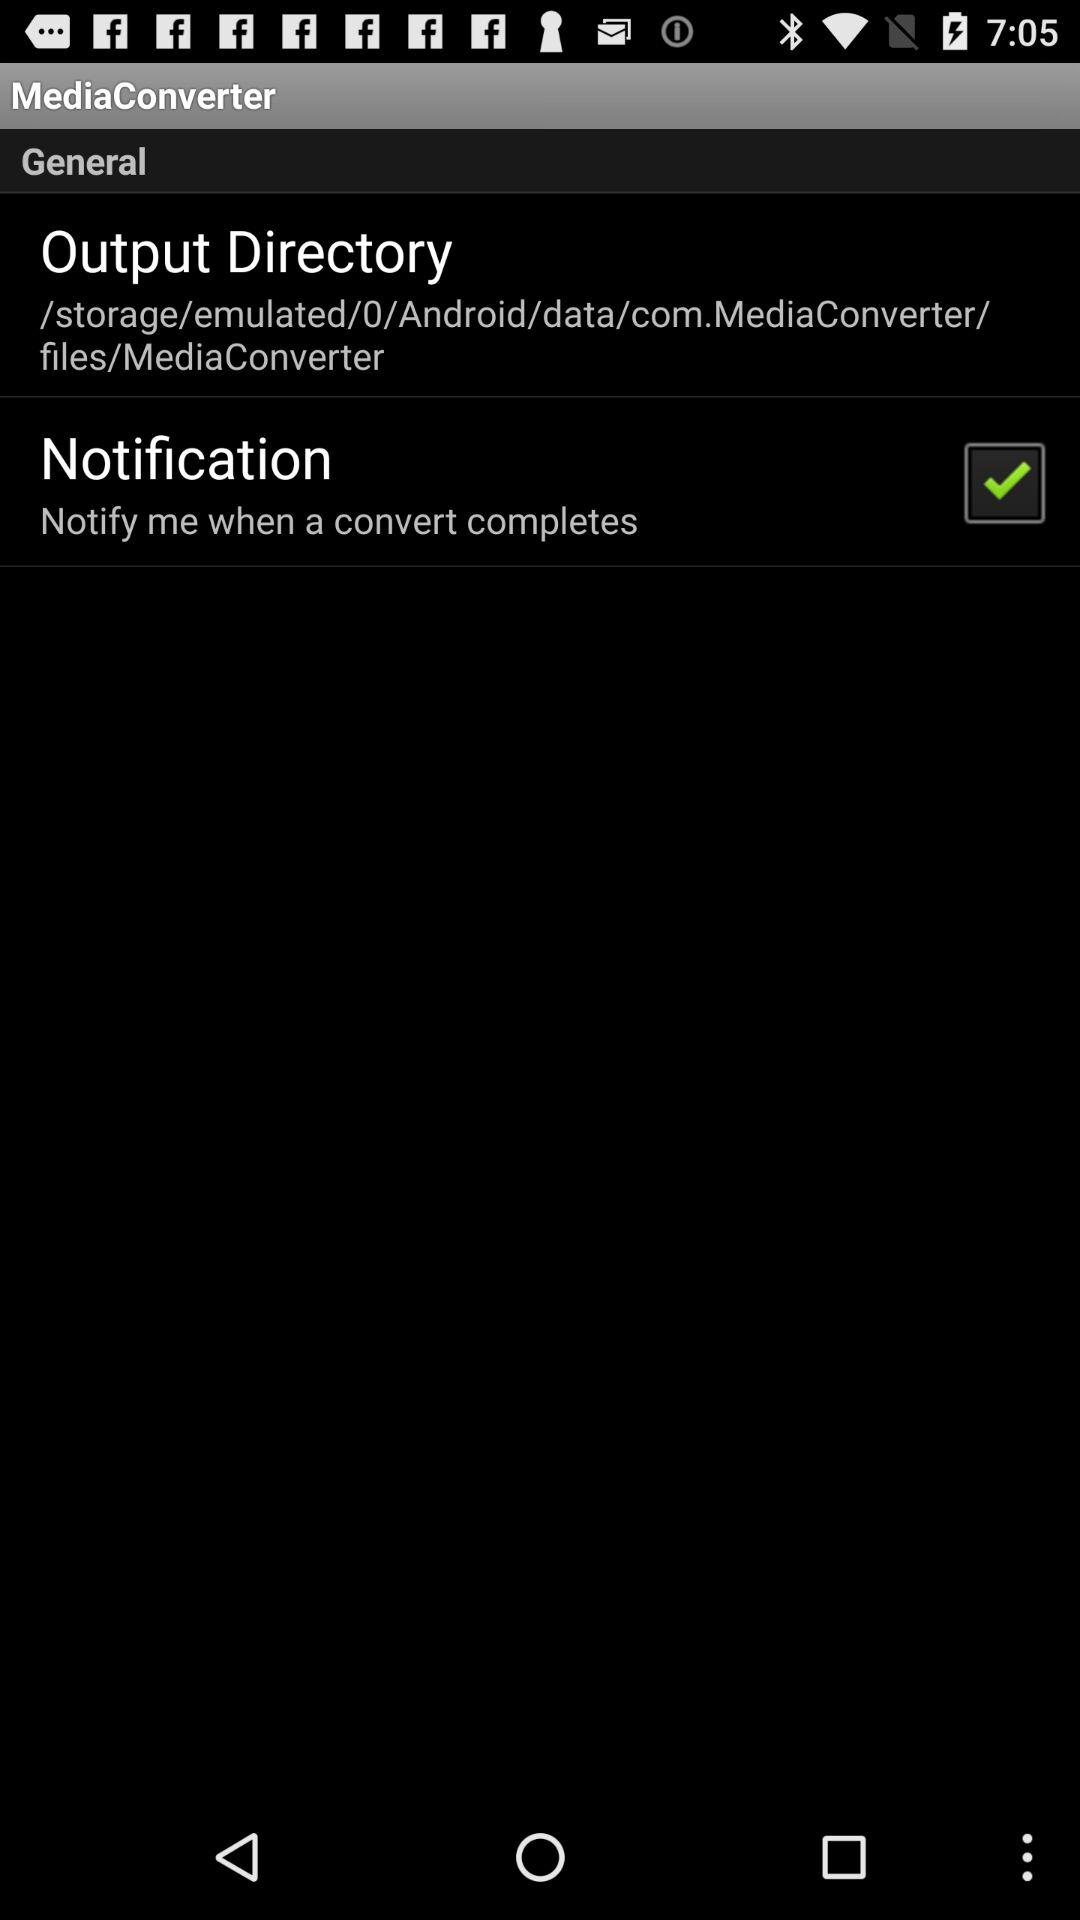What's the "Notification" status? The status is "on". 